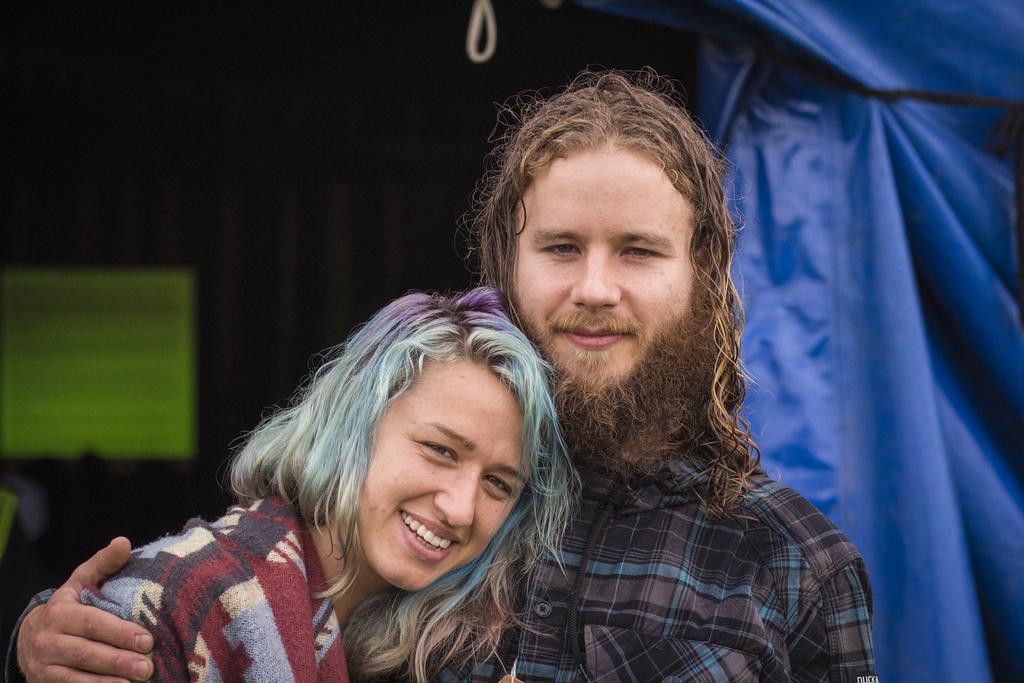Could you give a brief overview of what you see in this image? In the front of the image there is a man and a lady. Behind them there is a blue color cover. And also there is a blur background. 